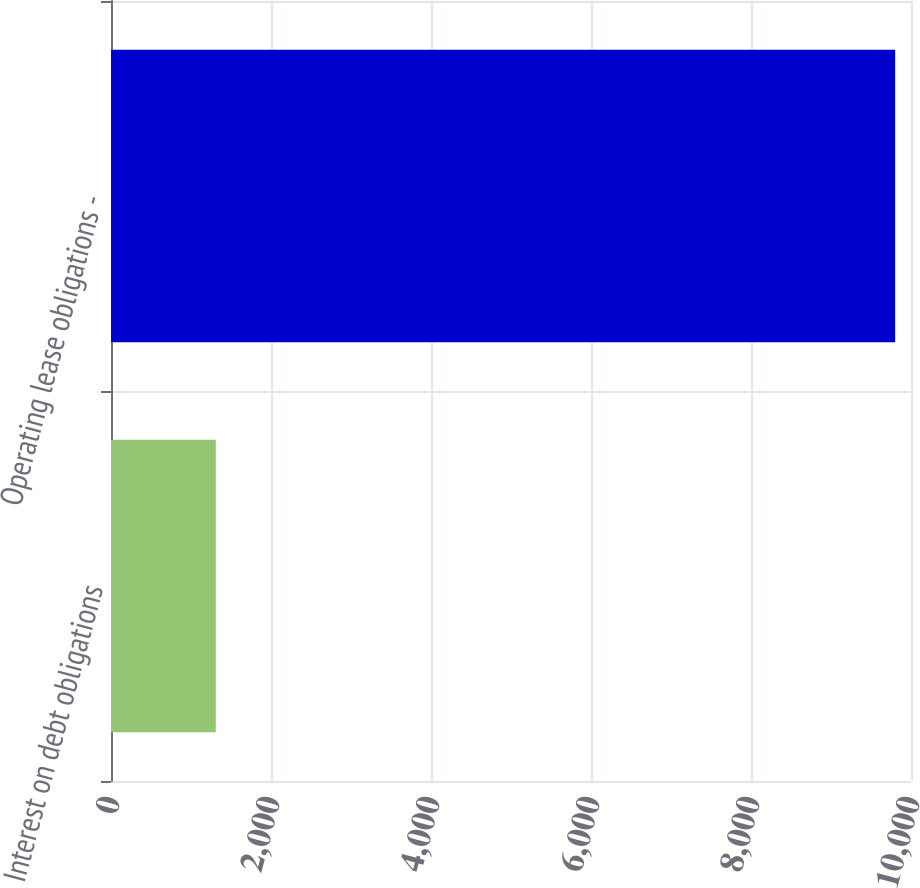Convert chart. <chart><loc_0><loc_0><loc_500><loc_500><bar_chart><fcel>Interest on debt obligations<fcel>Operating lease obligations -<nl><fcel>1310<fcel>9802<nl></chart> 